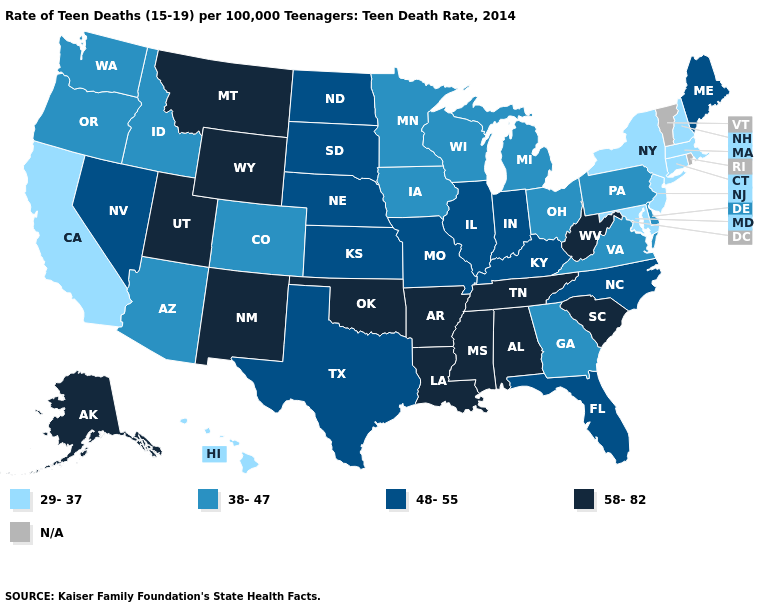What is the value of Illinois?
Answer briefly. 48-55. Does Maryland have the lowest value in the South?
Give a very brief answer. Yes. What is the highest value in states that border Kansas?
Keep it brief. 58-82. What is the highest value in the South ?
Answer briefly. 58-82. Which states have the highest value in the USA?
Give a very brief answer. Alabama, Alaska, Arkansas, Louisiana, Mississippi, Montana, New Mexico, Oklahoma, South Carolina, Tennessee, Utah, West Virginia, Wyoming. Does the map have missing data?
Quick response, please. Yes. Name the states that have a value in the range 58-82?
Concise answer only. Alabama, Alaska, Arkansas, Louisiana, Mississippi, Montana, New Mexico, Oklahoma, South Carolina, Tennessee, Utah, West Virginia, Wyoming. What is the lowest value in states that border Rhode Island?
Concise answer only. 29-37. Which states have the lowest value in the South?
Answer briefly. Maryland. How many symbols are there in the legend?
Be succinct. 5. Which states have the lowest value in the USA?
Write a very short answer. California, Connecticut, Hawaii, Maryland, Massachusetts, New Hampshire, New Jersey, New York. Does New York have the lowest value in the USA?
Short answer required. Yes. Which states have the highest value in the USA?
Answer briefly. Alabama, Alaska, Arkansas, Louisiana, Mississippi, Montana, New Mexico, Oklahoma, South Carolina, Tennessee, Utah, West Virginia, Wyoming. 